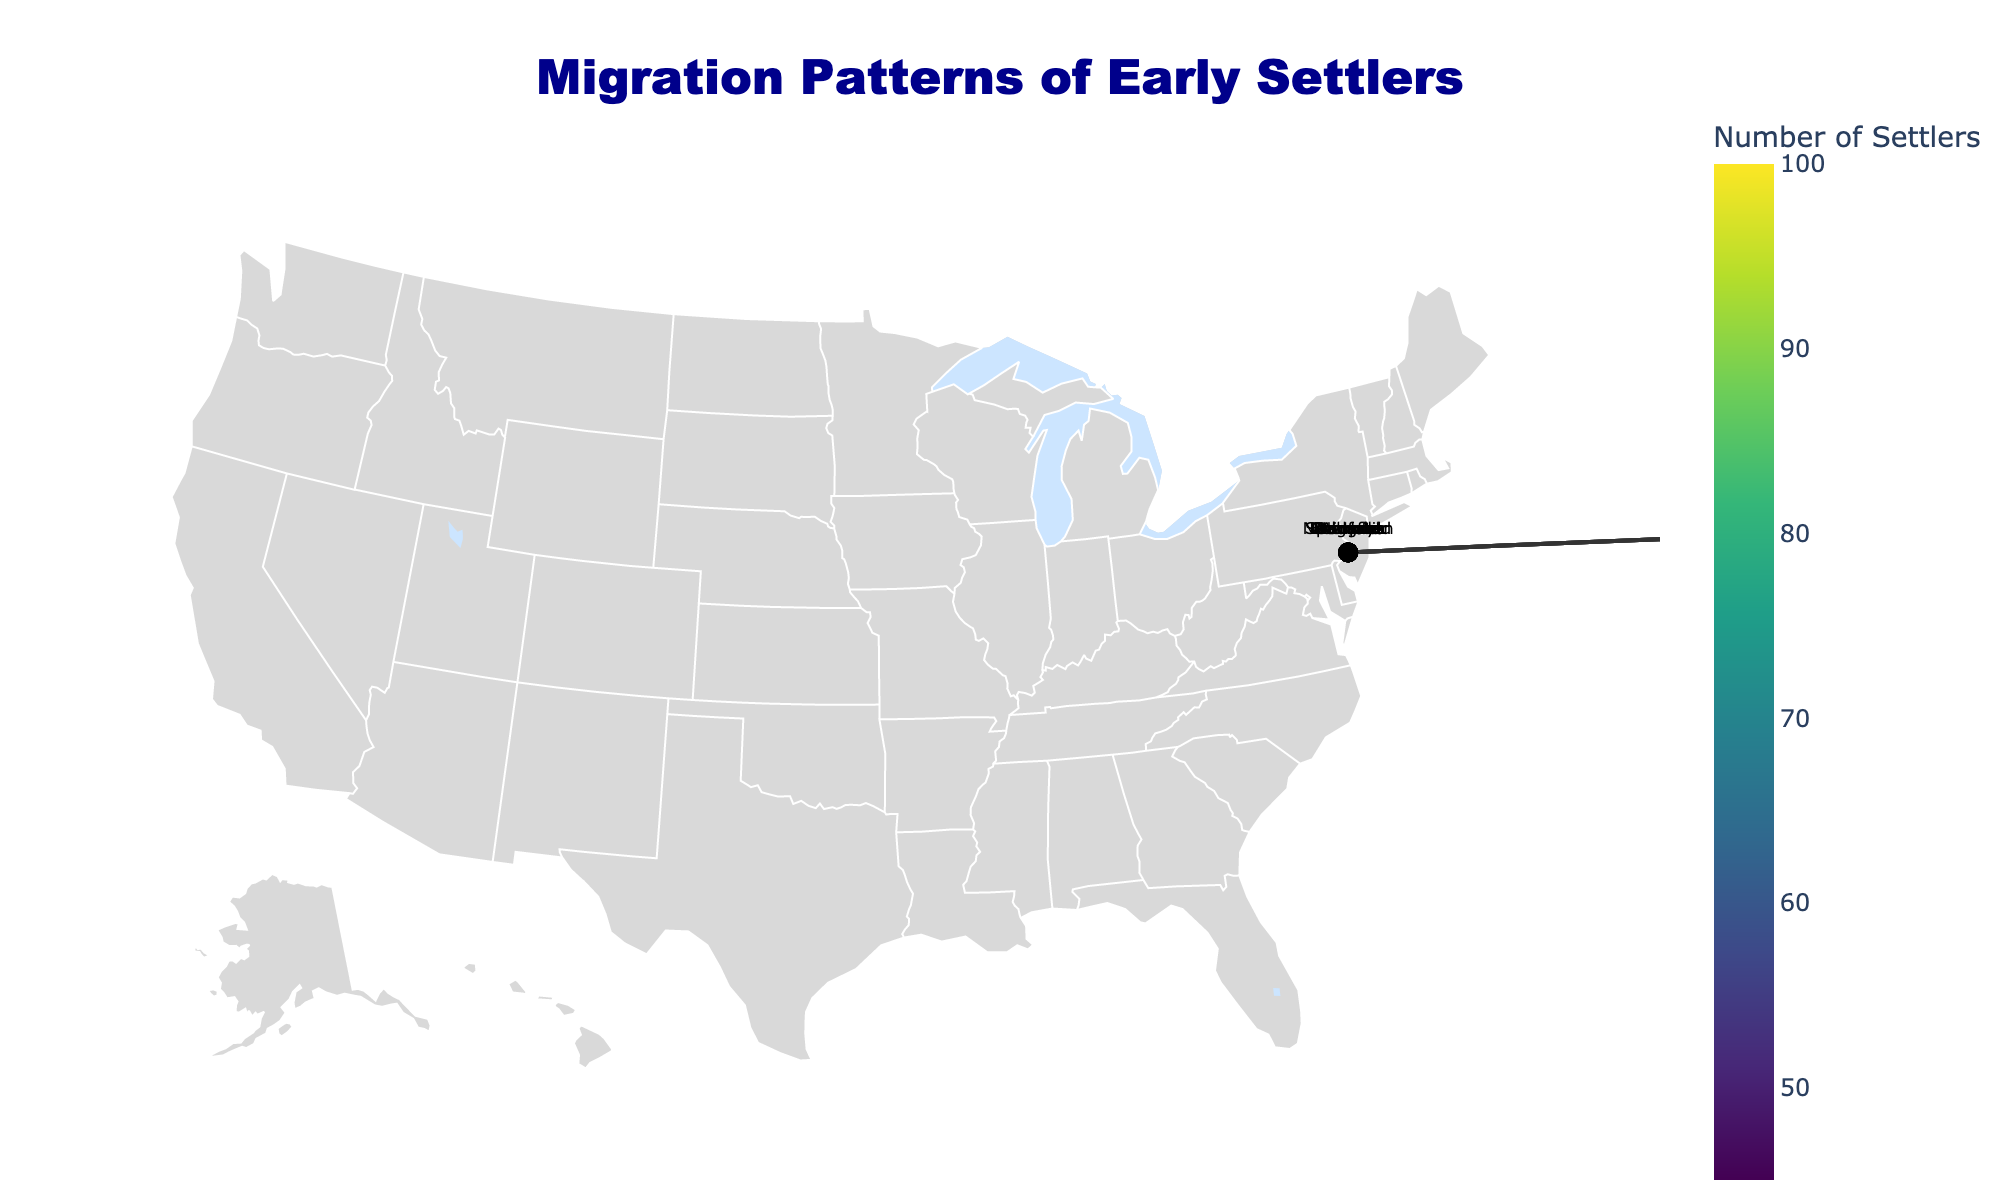How many migration paths are shown on the map? Count the number of lines representing the migration paths on the map. There should be as many lines as there are rows in the data.
Answer: 10 Which migration path had the highest number of settlers? Look at the color of the markers and refer to the color bar to determine which migration path corresponds to the highest value. The highest value is 100, which corresponds to the migration from Boston to Springfield.
Answer: Boston to Springfield What year had the latest recorded migration? Identify the year associated with each migration by looking at the labeled markers or paths and pick the latest one. The latest year in the dataset is 1786, which corresponds to Charleston to Columbia.
Answer: 1786 What is the combined total number of settlers from all migration paths? Sum the values of the "Number of Settlers" column: 100 + 75 + 85 + 60 + 50 + 70 + 55 + 65 + 80 + 45 = 685.
Answer: 685 Which migration path had the least number of settlers? Refer to the color bar and locate the migration path with the smallest value, which is 45 for the migration from Williamsburg to Norfolk.
Answer: Williamsburg to Norfolk What is the average number of settlers across all migration paths? First, find the total number of settlers (685). Then divide by the number of migration paths (10): 685 / 10 = 68.5.
Answer: 68.5 Which migration started the earliest? Identify the earliest year by looking at the labeled markers or paths. The earliest year in the dataset is 1624, corresponding to the migration from New York to Albany.
Answer: New York to Albany Do more settlers move from Northern cities or Southern cities? Categorize the cities into Northern (e.g., Boston, New York, Philadelphia, etc.) and Southern (e.g., Charleston, Savannah, etc.). Count the settlers for each category and compare. Northern cities have settlers moving as 100 + 85 + 75 + 65 + 80 = 405, Southern as 60 + 55 + 70 = 185, indicating that more settlers moved from Northern cities.
Answer: Northern cities Which city pair has the smallest gap in the number of settlers? Calculate the difference in the number of settlers for each pair and find the smallest one. Example for comparison: (100-75)=25, (85-80)=5, (70-65)=5, etc. The smallest gap, 5, is between New York to Albany (85) and Hartford to New Haven (80), as well as Providence to Newport (65) and Baltimore to Frederick (70).
Answer: (New York to Albany, Hartford to New Haven) or (Providence to Newport, Baltimore to Frederick) Which migration path has the highest difference in years between its origin and destination? Calculate the difference in years for each migration and find the highest one. Compare: (1786-1745)=41, etc. The highest difference is for Charleston to Columbia (1786) and Baltimore to Frederick (1745), giving a difference of 41 years.
Answer: Charleston to Columbia and Baltimore to Frederick 